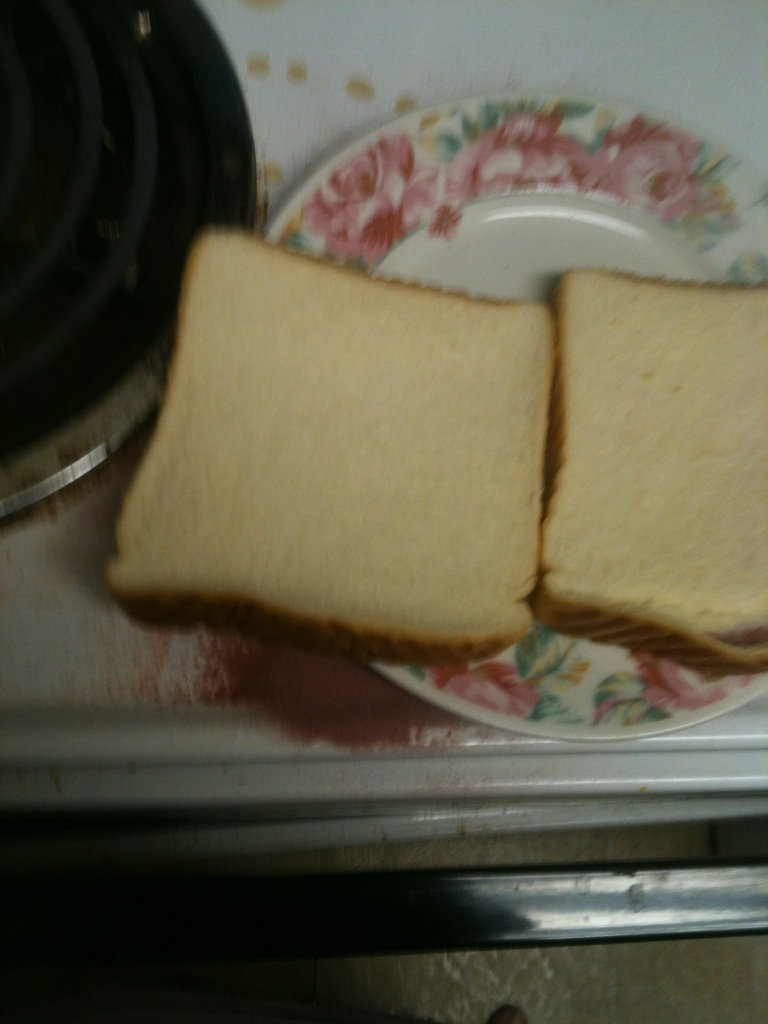Can you describe the color and texture of the bread in detail? Sure, the bread appears to be a standard white loaf with a soft, uniform texture. The crust is a light golden brown, indicating it's been baked properly, and the inner crumb is a consistent pale cream color, which is typical for white bread. There are no signs of grains or seeds, suggesting it's a plain white bread without additional ingredients. Does the plate have any significance? The plate the bread is resting on might not hold any particular significance beyond practical use. It's a floral-patterned plate, potentially indicating a preference for classic kitchenware designs or simply that it's part of a set in use. It adds a touch of homeliness to the setting. 